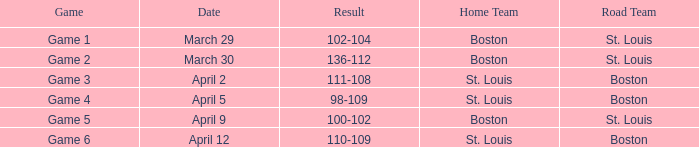What is the Result of Game 3? 111-108. 